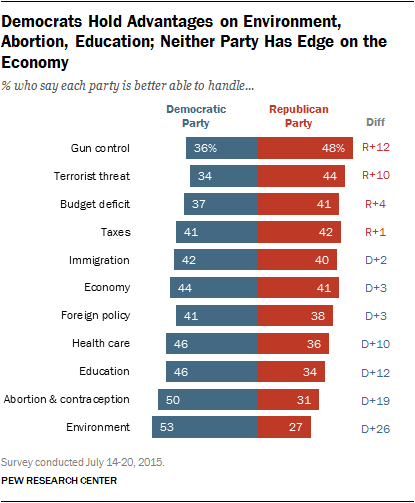List a handful of essential elements in this visual. The value of the economy in the bar is 44 and 41. The ratio between the Democratic and Republican parties in foreign policy is 1.0789... 